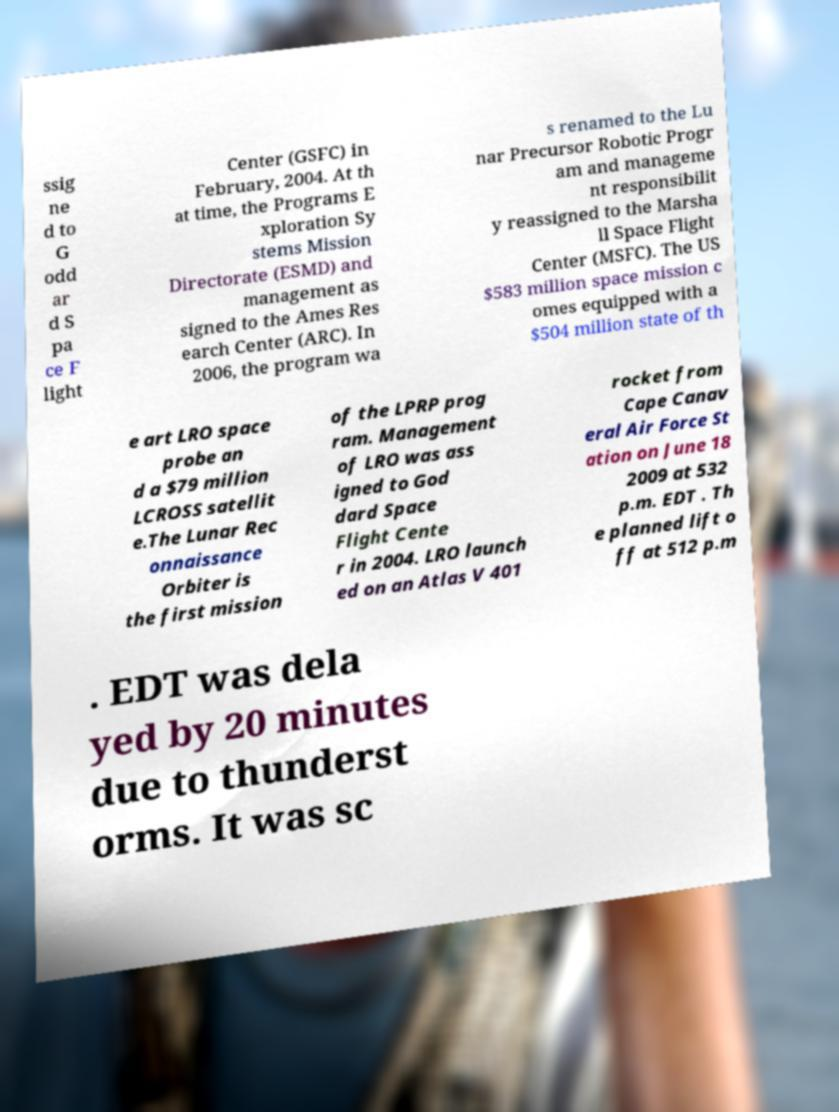Please read and relay the text visible in this image. What does it say? ssig ne d to G odd ar d S pa ce F light Center (GSFC) in February, 2004. At th at time, the Programs E xploration Sy stems Mission Directorate (ESMD) and management as signed to the Ames Res earch Center (ARC). In 2006, the program wa s renamed to the Lu nar Precursor Robotic Progr am and manageme nt responsibilit y reassigned to the Marsha ll Space Flight Center (MSFC). The US $583 million space mission c omes equipped with a $504 million state of th e art LRO space probe an d a $79 million LCROSS satellit e.The Lunar Rec onnaissance Orbiter is the first mission of the LPRP prog ram. Management of LRO was ass igned to God dard Space Flight Cente r in 2004. LRO launch ed on an Atlas V 401 rocket from Cape Canav eral Air Force St ation on June 18 2009 at 532 p.m. EDT . Th e planned lift o ff at 512 p.m . EDT was dela yed by 20 minutes due to thunderst orms. It was sc 